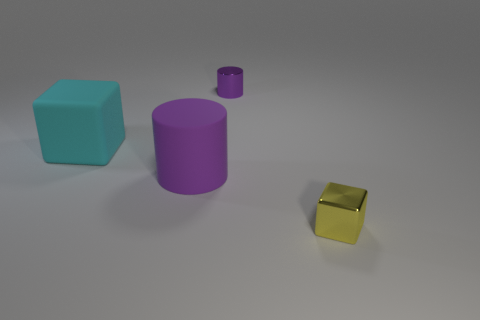Add 4 purple cylinders. How many objects exist? 8 Add 4 yellow things. How many yellow things are left? 5 Add 4 small cyan rubber objects. How many small cyan rubber objects exist? 4 Subtract 0 blue blocks. How many objects are left? 4 Subtract all purple cylinders. Subtract all tiny yellow things. How many objects are left? 1 